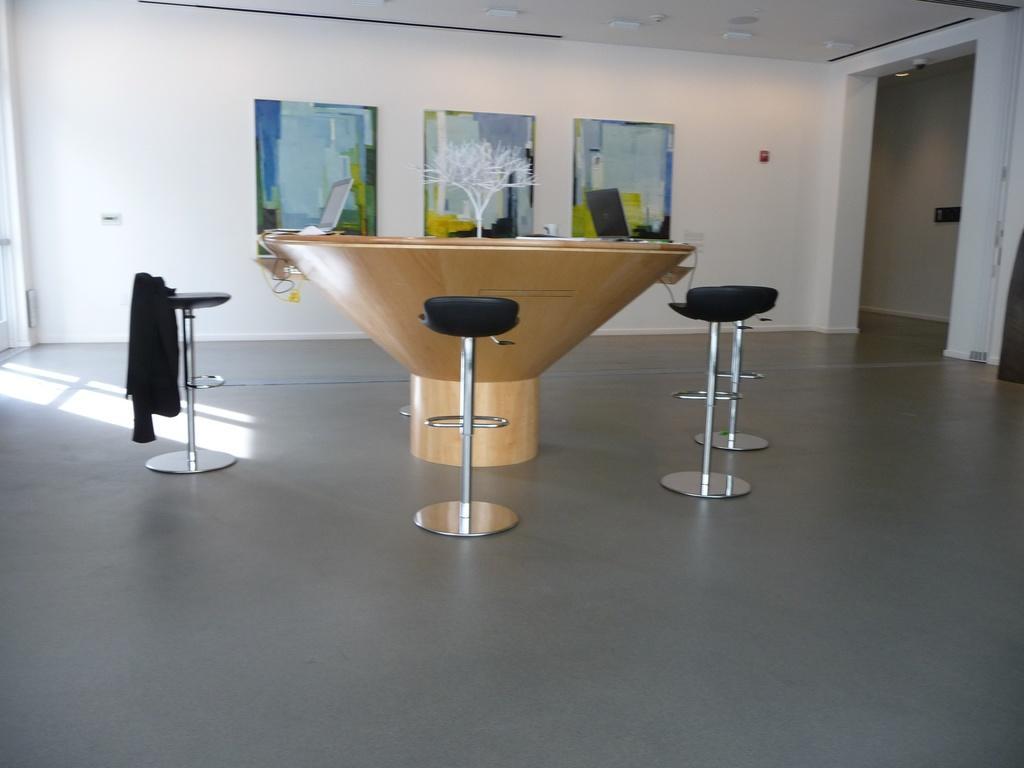Could you give a brief overview of what you see in this image? In this image there is a round table with a flower vase, laptops and a few other objects on it, around them there are chairs, one of the chair there is a cloth. In the background there are frames hanging on the wall. At the top of the image there is a ceiling. 